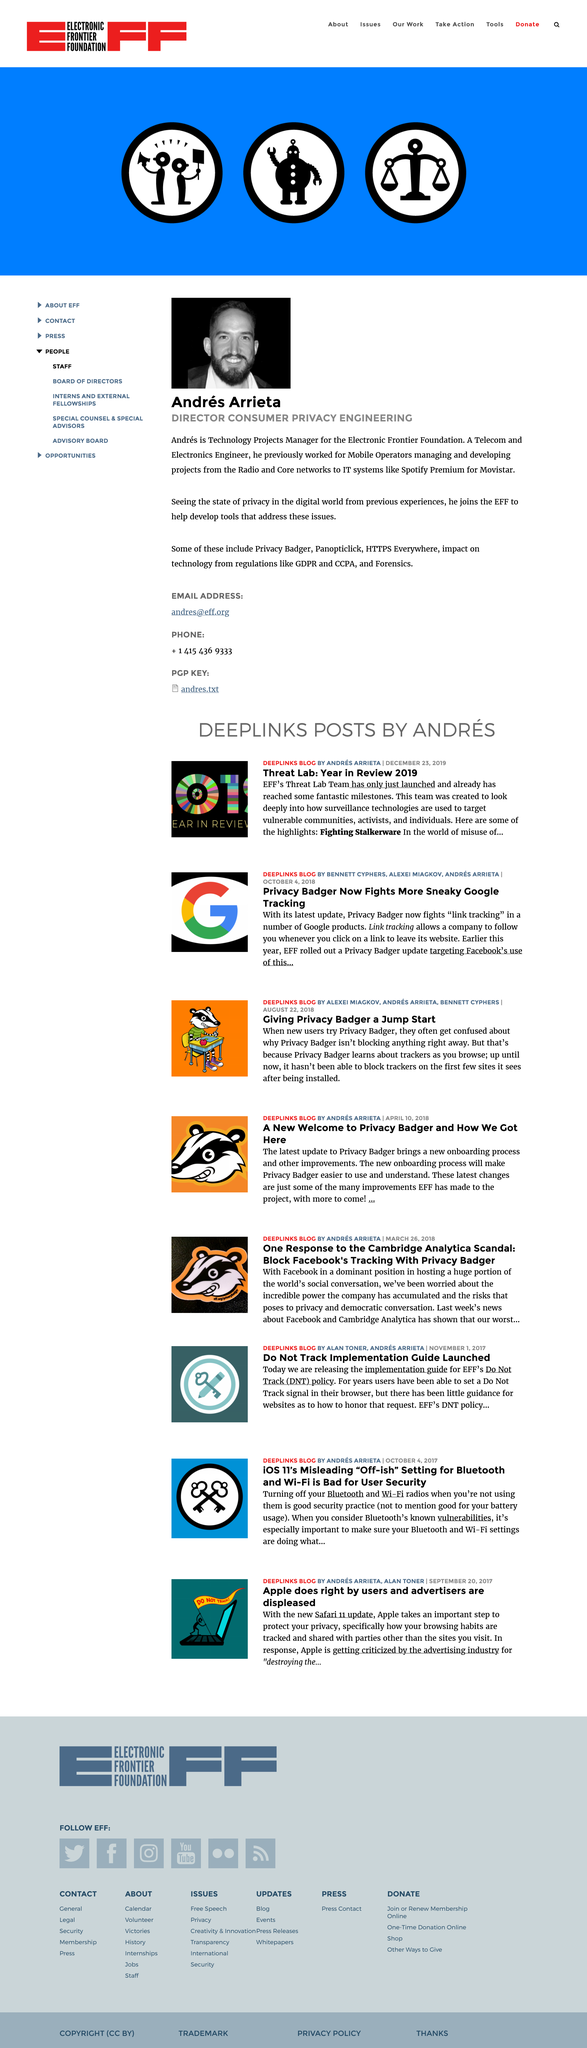Mention a couple of crucial points in this snapshot. Andres Arrieta joined the EFF to aid in the creation of tools that address the concerns of privacy in the digital realm. The identity of the man depicted in the photograph is Andres Arrieta. The Electronic Frontier Foundation, or EFF, is a nonprofit organization that advocates for civil liberties and protects privacy in the digital world. 